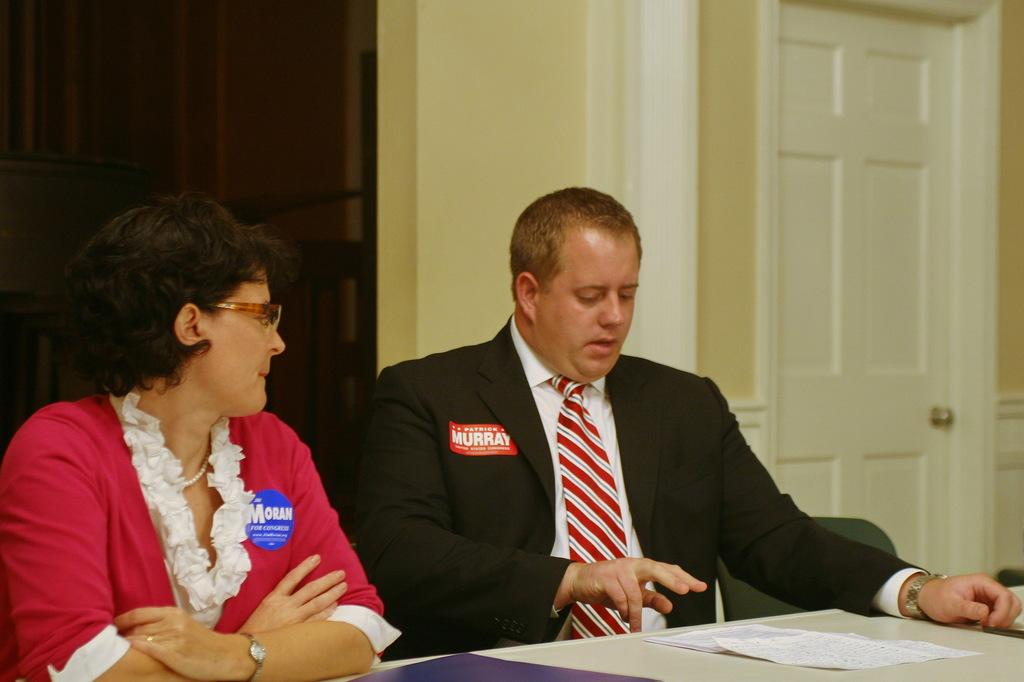How many people are present in the image? There are two persons sitting in the image. What is located behind the persons? There is a wall behind the persons. Can you describe any architectural features in the image? Yes, there is a door visible in the image. What type of furniture is present in the image? There is a chair in the image. What is on the surface in front of the persons? There is a paper on a surface in front of the persons. What type of pet can be seen running through the airport in the image? There is no pet or airport present in the image; it features two persons sitting with a paper on a surface in front of them. 